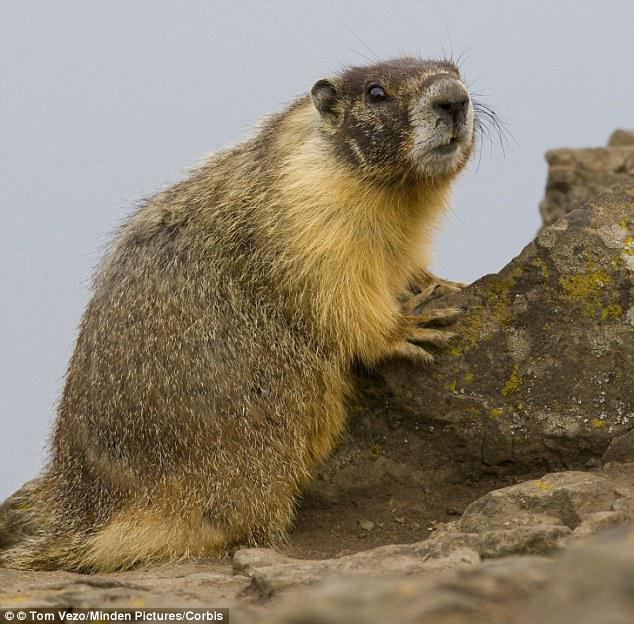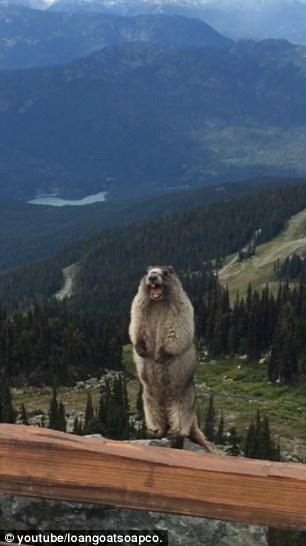The first image is the image on the left, the second image is the image on the right. Given the left and right images, does the statement "In one image, a groundhog is standing up on its hind legs." hold true? Answer yes or no. Yes. The first image is the image on the left, the second image is the image on the right. Analyze the images presented: Is the assertion "Exactly one of the images has the animal with its front paws pressed up against a rock while the front paws are elevated higher than it's back paws." valid? Answer yes or no. Yes. 